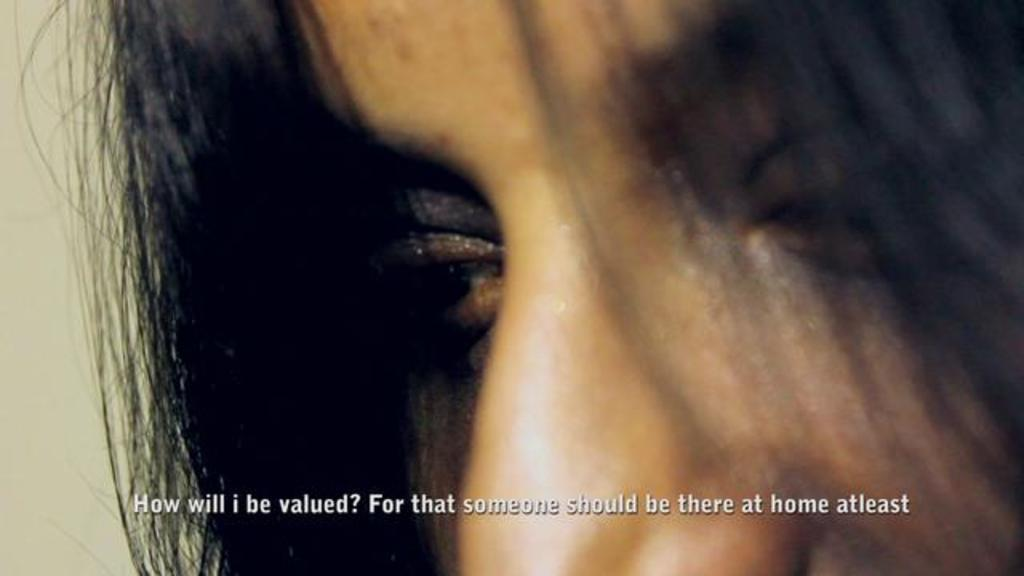What is the main subject of the image? There is a human face in the center of the image. What can be seen behind the human face? There is a wall in the background of the image. What type of verse is being recited by the human face in the image? There is no indication in the image that the human face is reciting any verse, so it cannot be determined from the picture. 